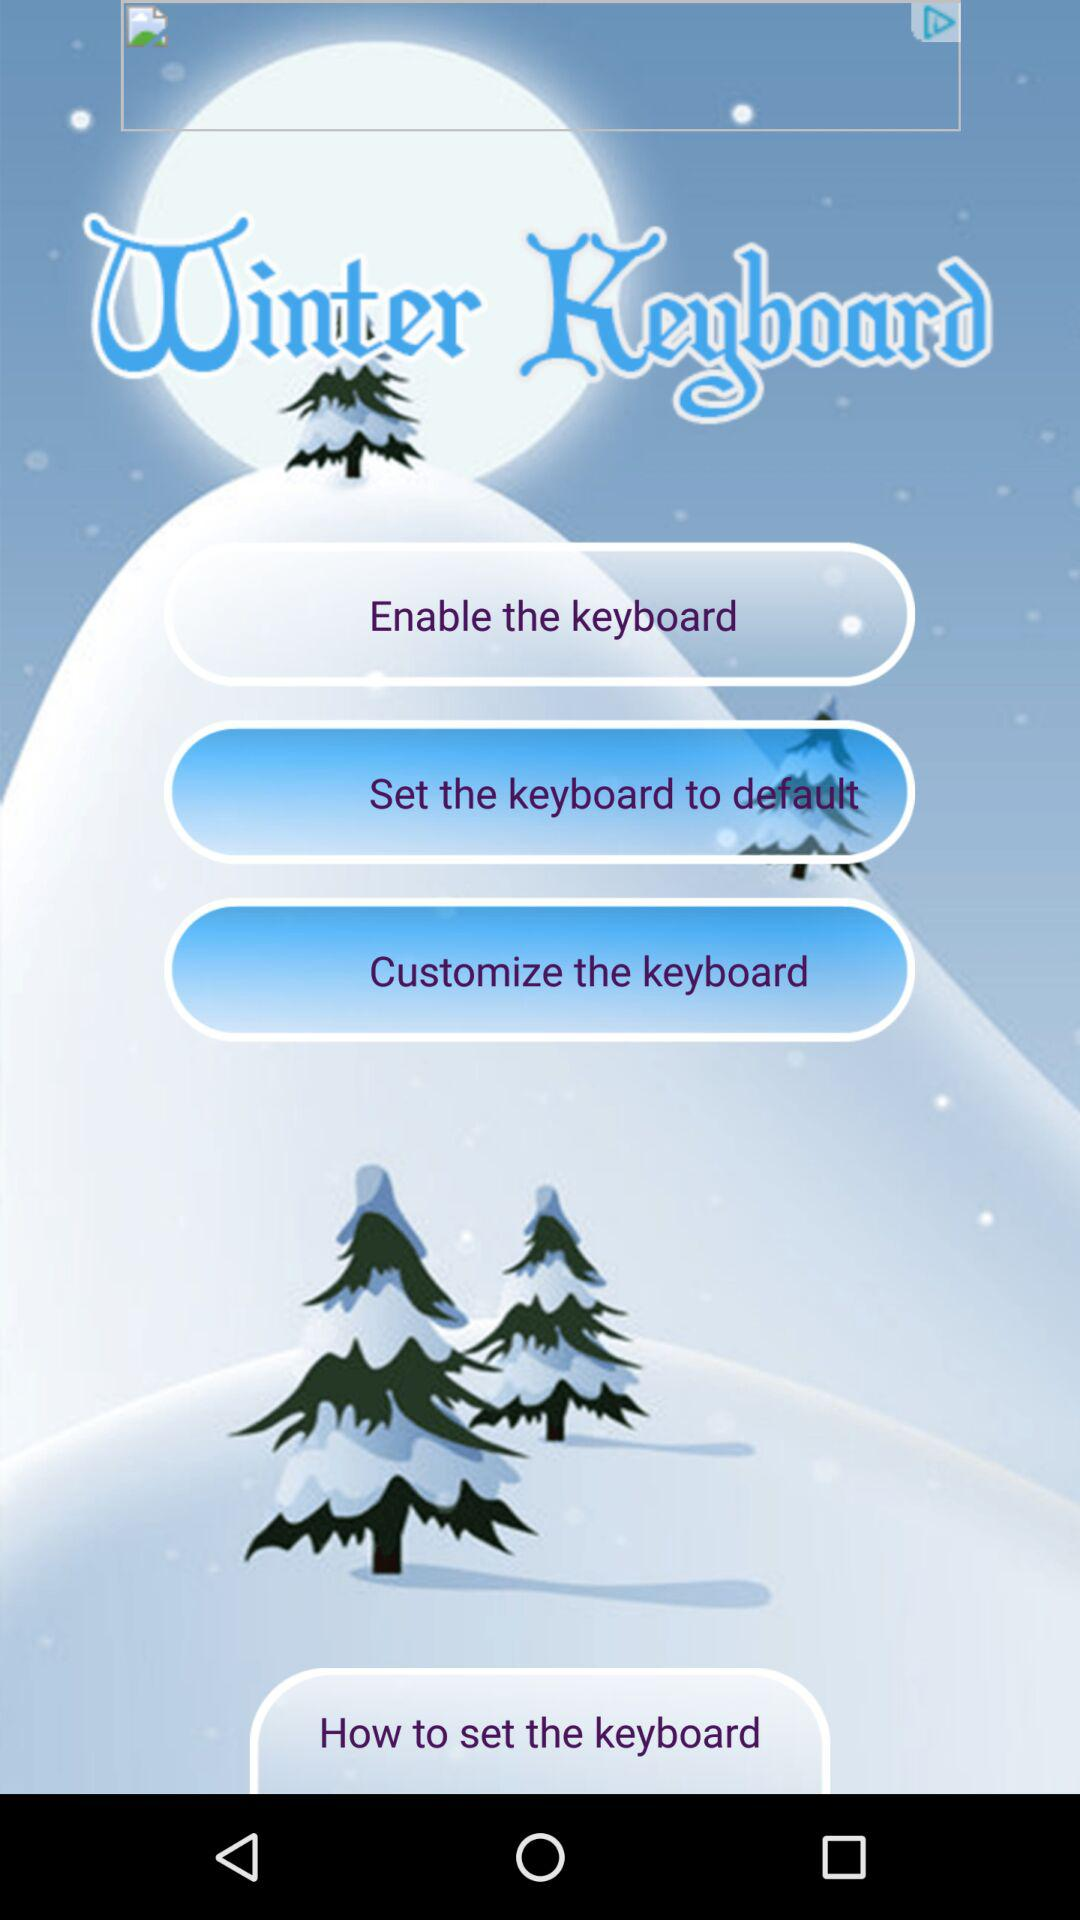What's the selected option in "Winter Keyboard"? The selected option in "Winter Keyboard" is "Enable the keyboard". 